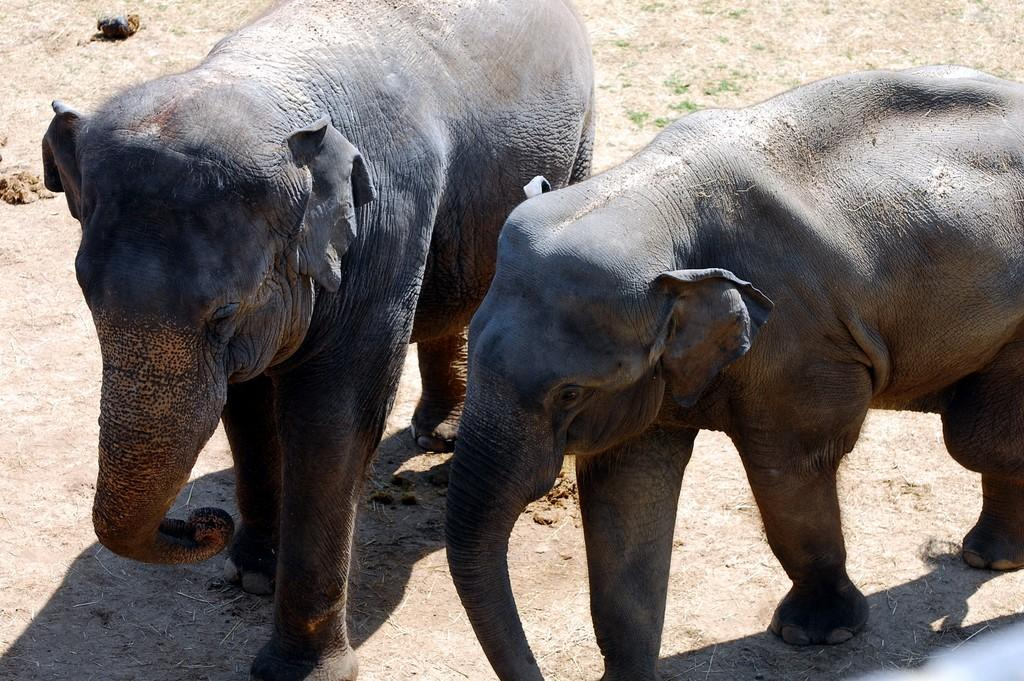How many elephants are in the picture? There are two elephants in the picture. What type of terrain is depicted at the bottom of the image? The bottom of the image depicts land. What advice does the grandmother give to the elephants in the image? There is no grandmother present in the image, so no advice can be given. 